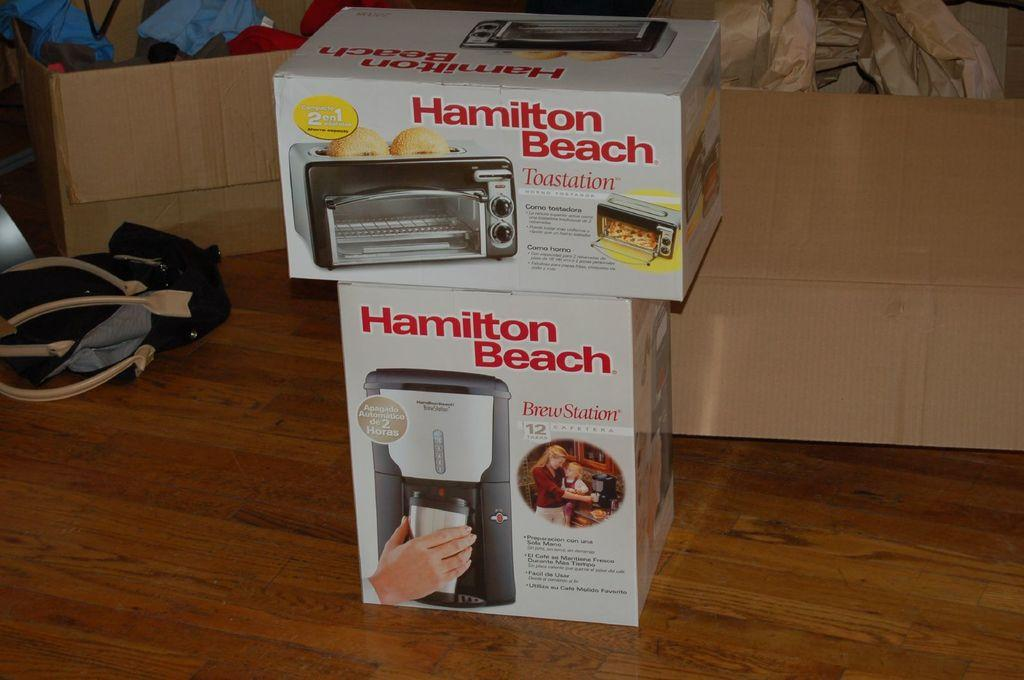<image>
Write a terse but informative summary of the picture. A Hamilton Beach toaster oven box sits on top of a Hamilton Beach coffee maker box. 